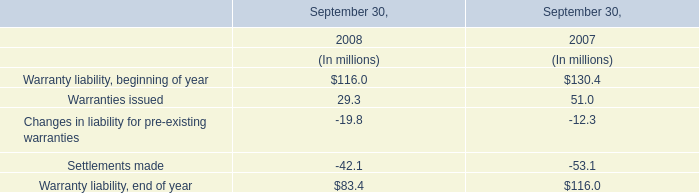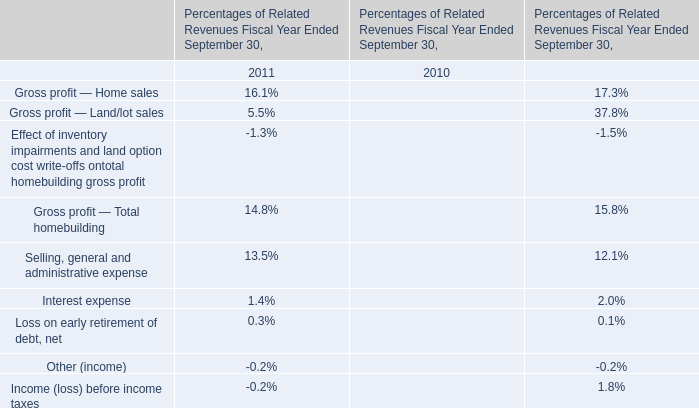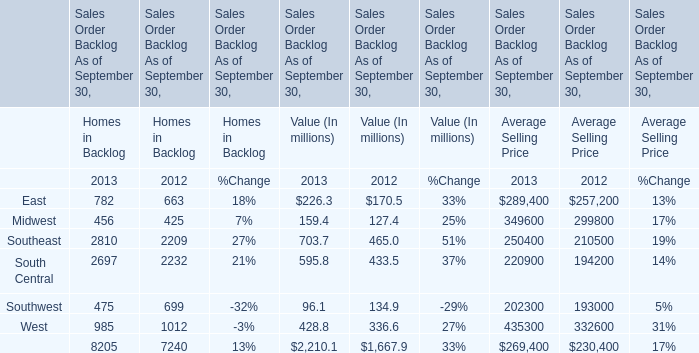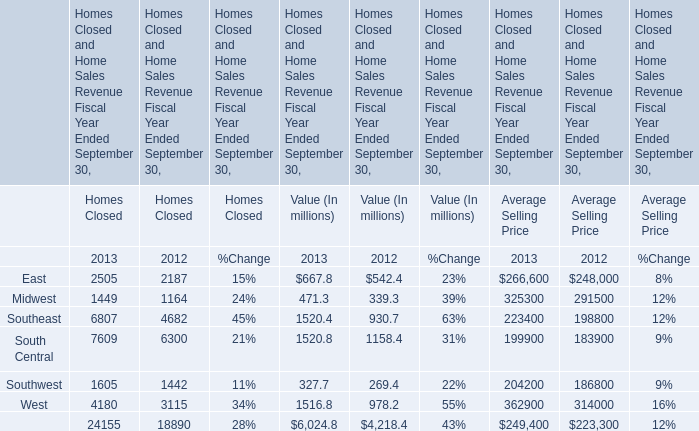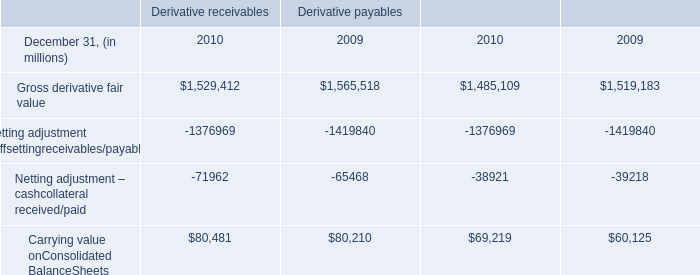In the year with largest amount of East for Homes in Backlog, what's the increasing rate of Midwest? 
Computations: ((456 - 425) / 456)
Answer: 0.06798. 